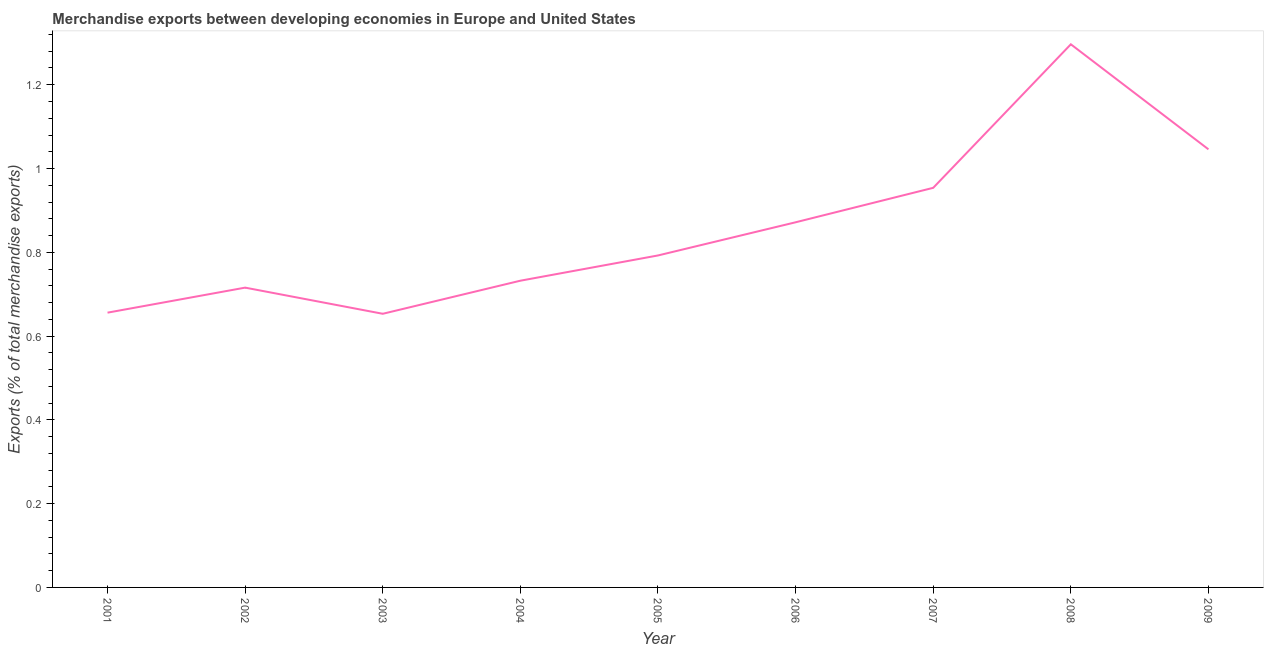What is the merchandise exports in 2005?
Your answer should be compact. 0.79. Across all years, what is the maximum merchandise exports?
Make the answer very short. 1.3. Across all years, what is the minimum merchandise exports?
Keep it short and to the point. 0.65. In which year was the merchandise exports maximum?
Your response must be concise. 2008. What is the sum of the merchandise exports?
Provide a short and direct response. 7.72. What is the difference between the merchandise exports in 2006 and 2007?
Offer a terse response. -0.08. What is the average merchandise exports per year?
Your answer should be very brief. 0.86. What is the median merchandise exports?
Your response must be concise. 0.79. In how many years, is the merchandise exports greater than 1.04 %?
Provide a succinct answer. 2. What is the ratio of the merchandise exports in 2002 to that in 2008?
Give a very brief answer. 0.55. Is the merchandise exports in 2003 less than that in 2006?
Give a very brief answer. Yes. What is the difference between the highest and the second highest merchandise exports?
Offer a terse response. 0.25. What is the difference between the highest and the lowest merchandise exports?
Provide a short and direct response. 0.64. In how many years, is the merchandise exports greater than the average merchandise exports taken over all years?
Your response must be concise. 4. What is the difference between two consecutive major ticks on the Y-axis?
Your answer should be compact. 0.2. What is the title of the graph?
Provide a succinct answer. Merchandise exports between developing economies in Europe and United States. What is the label or title of the Y-axis?
Provide a short and direct response. Exports (% of total merchandise exports). What is the Exports (% of total merchandise exports) of 2001?
Provide a succinct answer. 0.66. What is the Exports (% of total merchandise exports) in 2002?
Provide a succinct answer. 0.72. What is the Exports (% of total merchandise exports) of 2003?
Give a very brief answer. 0.65. What is the Exports (% of total merchandise exports) of 2004?
Ensure brevity in your answer.  0.73. What is the Exports (% of total merchandise exports) in 2005?
Your answer should be compact. 0.79. What is the Exports (% of total merchandise exports) of 2006?
Keep it short and to the point. 0.87. What is the Exports (% of total merchandise exports) in 2007?
Give a very brief answer. 0.95. What is the Exports (% of total merchandise exports) in 2008?
Make the answer very short. 1.3. What is the Exports (% of total merchandise exports) of 2009?
Provide a succinct answer. 1.05. What is the difference between the Exports (% of total merchandise exports) in 2001 and 2002?
Provide a short and direct response. -0.06. What is the difference between the Exports (% of total merchandise exports) in 2001 and 2003?
Offer a very short reply. 0. What is the difference between the Exports (% of total merchandise exports) in 2001 and 2004?
Your answer should be compact. -0.08. What is the difference between the Exports (% of total merchandise exports) in 2001 and 2005?
Offer a very short reply. -0.14. What is the difference between the Exports (% of total merchandise exports) in 2001 and 2006?
Offer a very short reply. -0.22. What is the difference between the Exports (% of total merchandise exports) in 2001 and 2007?
Keep it short and to the point. -0.3. What is the difference between the Exports (% of total merchandise exports) in 2001 and 2008?
Give a very brief answer. -0.64. What is the difference between the Exports (% of total merchandise exports) in 2001 and 2009?
Offer a very short reply. -0.39. What is the difference between the Exports (% of total merchandise exports) in 2002 and 2003?
Offer a very short reply. 0.06. What is the difference between the Exports (% of total merchandise exports) in 2002 and 2004?
Your answer should be very brief. -0.02. What is the difference between the Exports (% of total merchandise exports) in 2002 and 2005?
Ensure brevity in your answer.  -0.08. What is the difference between the Exports (% of total merchandise exports) in 2002 and 2006?
Ensure brevity in your answer.  -0.16. What is the difference between the Exports (% of total merchandise exports) in 2002 and 2007?
Your answer should be compact. -0.24. What is the difference between the Exports (% of total merchandise exports) in 2002 and 2008?
Offer a terse response. -0.58. What is the difference between the Exports (% of total merchandise exports) in 2002 and 2009?
Offer a terse response. -0.33. What is the difference between the Exports (% of total merchandise exports) in 2003 and 2004?
Your answer should be very brief. -0.08. What is the difference between the Exports (% of total merchandise exports) in 2003 and 2005?
Your answer should be compact. -0.14. What is the difference between the Exports (% of total merchandise exports) in 2003 and 2006?
Your answer should be very brief. -0.22. What is the difference between the Exports (% of total merchandise exports) in 2003 and 2007?
Your answer should be very brief. -0.3. What is the difference between the Exports (% of total merchandise exports) in 2003 and 2008?
Offer a very short reply. -0.64. What is the difference between the Exports (% of total merchandise exports) in 2003 and 2009?
Make the answer very short. -0.39. What is the difference between the Exports (% of total merchandise exports) in 2004 and 2005?
Offer a terse response. -0.06. What is the difference between the Exports (% of total merchandise exports) in 2004 and 2006?
Provide a succinct answer. -0.14. What is the difference between the Exports (% of total merchandise exports) in 2004 and 2007?
Keep it short and to the point. -0.22. What is the difference between the Exports (% of total merchandise exports) in 2004 and 2008?
Your response must be concise. -0.56. What is the difference between the Exports (% of total merchandise exports) in 2004 and 2009?
Ensure brevity in your answer.  -0.31. What is the difference between the Exports (% of total merchandise exports) in 2005 and 2006?
Offer a very short reply. -0.08. What is the difference between the Exports (% of total merchandise exports) in 2005 and 2007?
Give a very brief answer. -0.16. What is the difference between the Exports (% of total merchandise exports) in 2005 and 2008?
Your answer should be compact. -0.5. What is the difference between the Exports (% of total merchandise exports) in 2005 and 2009?
Offer a terse response. -0.25. What is the difference between the Exports (% of total merchandise exports) in 2006 and 2007?
Your response must be concise. -0.08. What is the difference between the Exports (% of total merchandise exports) in 2006 and 2008?
Keep it short and to the point. -0.42. What is the difference between the Exports (% of total merchandise exports) in 2006 and 2009?
Keep it short and to the point. -0.17. What is the difference between the Exports (% of total merchandise exports) in 2007 and 2008?
Make the answer very short. -0.34. What is the difference between the Exports (% of total merchandise exports) in 2007 and 2009?
Keep it short and to the point. -0.09. What is the difference between the Exports (% of total merchandise exports) in 2008 and 2009?
Ensure brevity in your answer.  0.25. What is the ratio of the Exports (% of total merchandise exports) in 2001 to that in 2002?
Provide a short and direct response. 0.92. What is the ratio of the Exports (% of total merchandise exports) in 2001 to that in 2003?
Your answer should be very brief. 1. What is the ratio of the Exports (% of total merchandise exports) in 2001 to that in 2004?
Make the answer very short. 0.9. What is the ratio of the Exports (% of total merchandise exports) in 2001 to that in 2005?
Keep it short and to the point. 0.83. What is the ratio of the Exports (% of total merchandise exports) in 2001 to that in 2006?
Ensure brevity in your answer.  0.75. What is the ratio of the Exports (% of total merchandise exports) in 2001 to that in 2007?
Your answer should be very brief. 0.69. What is the ratio of the Exports (% of total merchandise exports) in 2001 to that in 2008?
Your response must be concise. 0.51. What is the ratio of the Exports (% of total merchandise exports) in 2001 to that in 2009?
Your response must be concise. 0.63. What is the ratio of the Exports (% of total merchandise exports) in 2002 to that in 2003?
Offer a very short reply. 1.1. What is the ratio of the Exports (% of total merchandise exports) in 2002 to that in 2004?
Your answer should be very brief. 0.98. What is the ratio of the Exports (% of total merchandise exports) in 2002 to that in 2005?
Give a very brief answer. 0.9. What is the ratio of the Exports (% of total merchandise exports) in 2002 to that in 2006?
Provide a succinct answer. 0.82. What is the ratio of the Exports (% of total merchandise exports) in 2002 to that in 2008?
Your response must be concise. 0.55. What is the ratio of the Exports (% of total merchandise exports) in 2002 to that in 2009?
Offer a very short reply. 0.68. What is the ratio of the Exports (% of total merchandise exports) in 2003 to that in 2004?
Your answer should be very brief. 0.89. What is the ratio of the Exports (% of total merchandise exports) in 2003 to that in 2005?
Provide a succinct answer. 0.82. What is the ratio of the Exports (% of total merchandise exports) in 2003 to that in 2006?
Ensure brevity in your answer.  0.75. What is the ratio of the Exports (% of total merchandise exports) in 2003 to that in 2007?
Provide a short and direct response. 0.69. What is the ratio of the Exports (% of total merchandise exports) in 2003 to that in 2008?
Ensure brevity in your answer.  0.5. What is the ratio of the Exports (% of total merchandise exports) in 2003 to that in 2009?
Give a very brief answer. 0.62. What is the ratio of the Exports (% of total merchandise exports) in 2004 to that in 2005?
Ensure brevity in your answer.  0.92. What is the ratio of the Exports (% of total merchandise exports) in 2004 to that in 2006?
Make the answer very short. 0.84. What is the ratio of the Exports (% of total merchandise exports) in 2004 to that in 2007?
Make the answer very short. 0.77. What is the ratio of the Exports (% of total merchandise exports) in 2004 to that in 2008?
Keep it short and to the point. 0.56. What is the ratio of the Exports (% of total merchandise exports) in 2004 to that in 2009?
Offer a very short reply. 0.7. What is the ratio of the Exports (% of total merchandise exports) in 2005 to that in 2006?
Offer a terse response. 0.91. What is the ratio of the Exports (% of total merchandise exports) in 2005 to that in 2007?
Provide a succinct answer. 0.83. What is the ratio of the Exports (% of total merchandise exports) in 2005 to that in 2008?
Offer a very short reply. 0.61. What is the ratio of the Exports (% of total merchandise exports) in 2005 to that in 2009?
Make the answer very short. 0.76. What is the ratio of the Exports (% of total merchandise exports) in 2006 to that in 2007?
Ensure brevity in your answer.  0.91. What is the ratio of the Exports (% of total merchandise exports) in 2006 to that in 2008?
Provide a short and direct response. 0.67. What is the ratio of the Exports (% of total merchandise exports) in 2006 to that in 2009?
Your answer should be compact. 0.83. What is the ratio of the Exports (% of total merchandise exports) in 2007 to that in 2008?
Provide a short and direct response. 0.74. What is the ratio of the Exports (% of total merchandise exports) in 2007 to that in 2009?
Give a very brief answer. 0.91. What is the ratio of the Exports (% of total merchandise exports) in 2008 to that in 2009?
Ensure brevity in your answer.  1.24. 